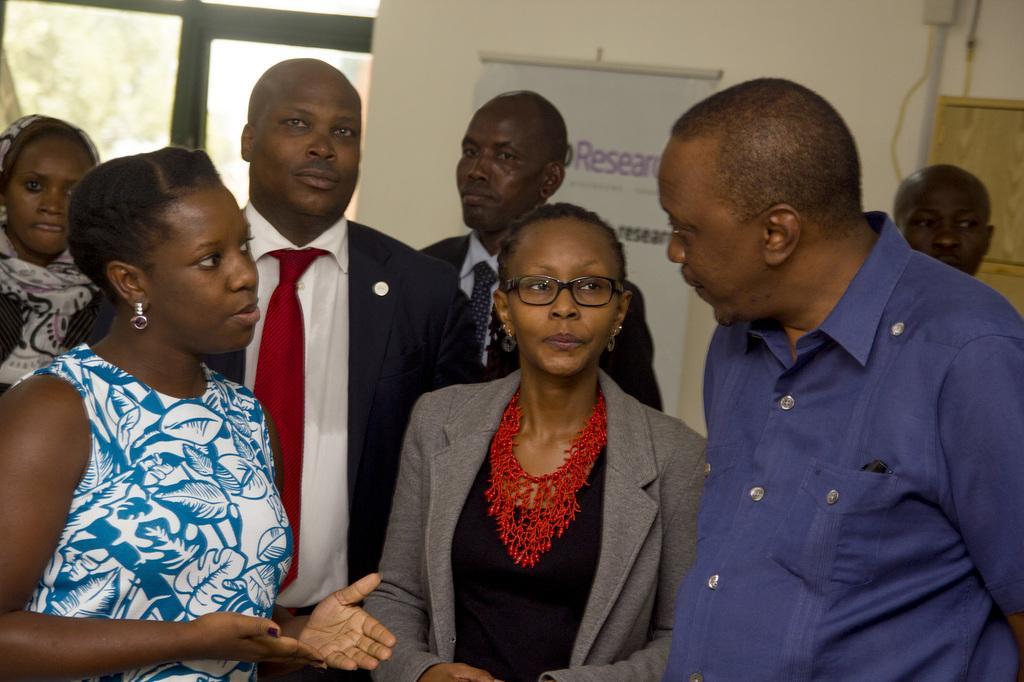Can you describe this image briefly? In this picture I can see group of people standing, there is a banner, and in the background there is a wall. 